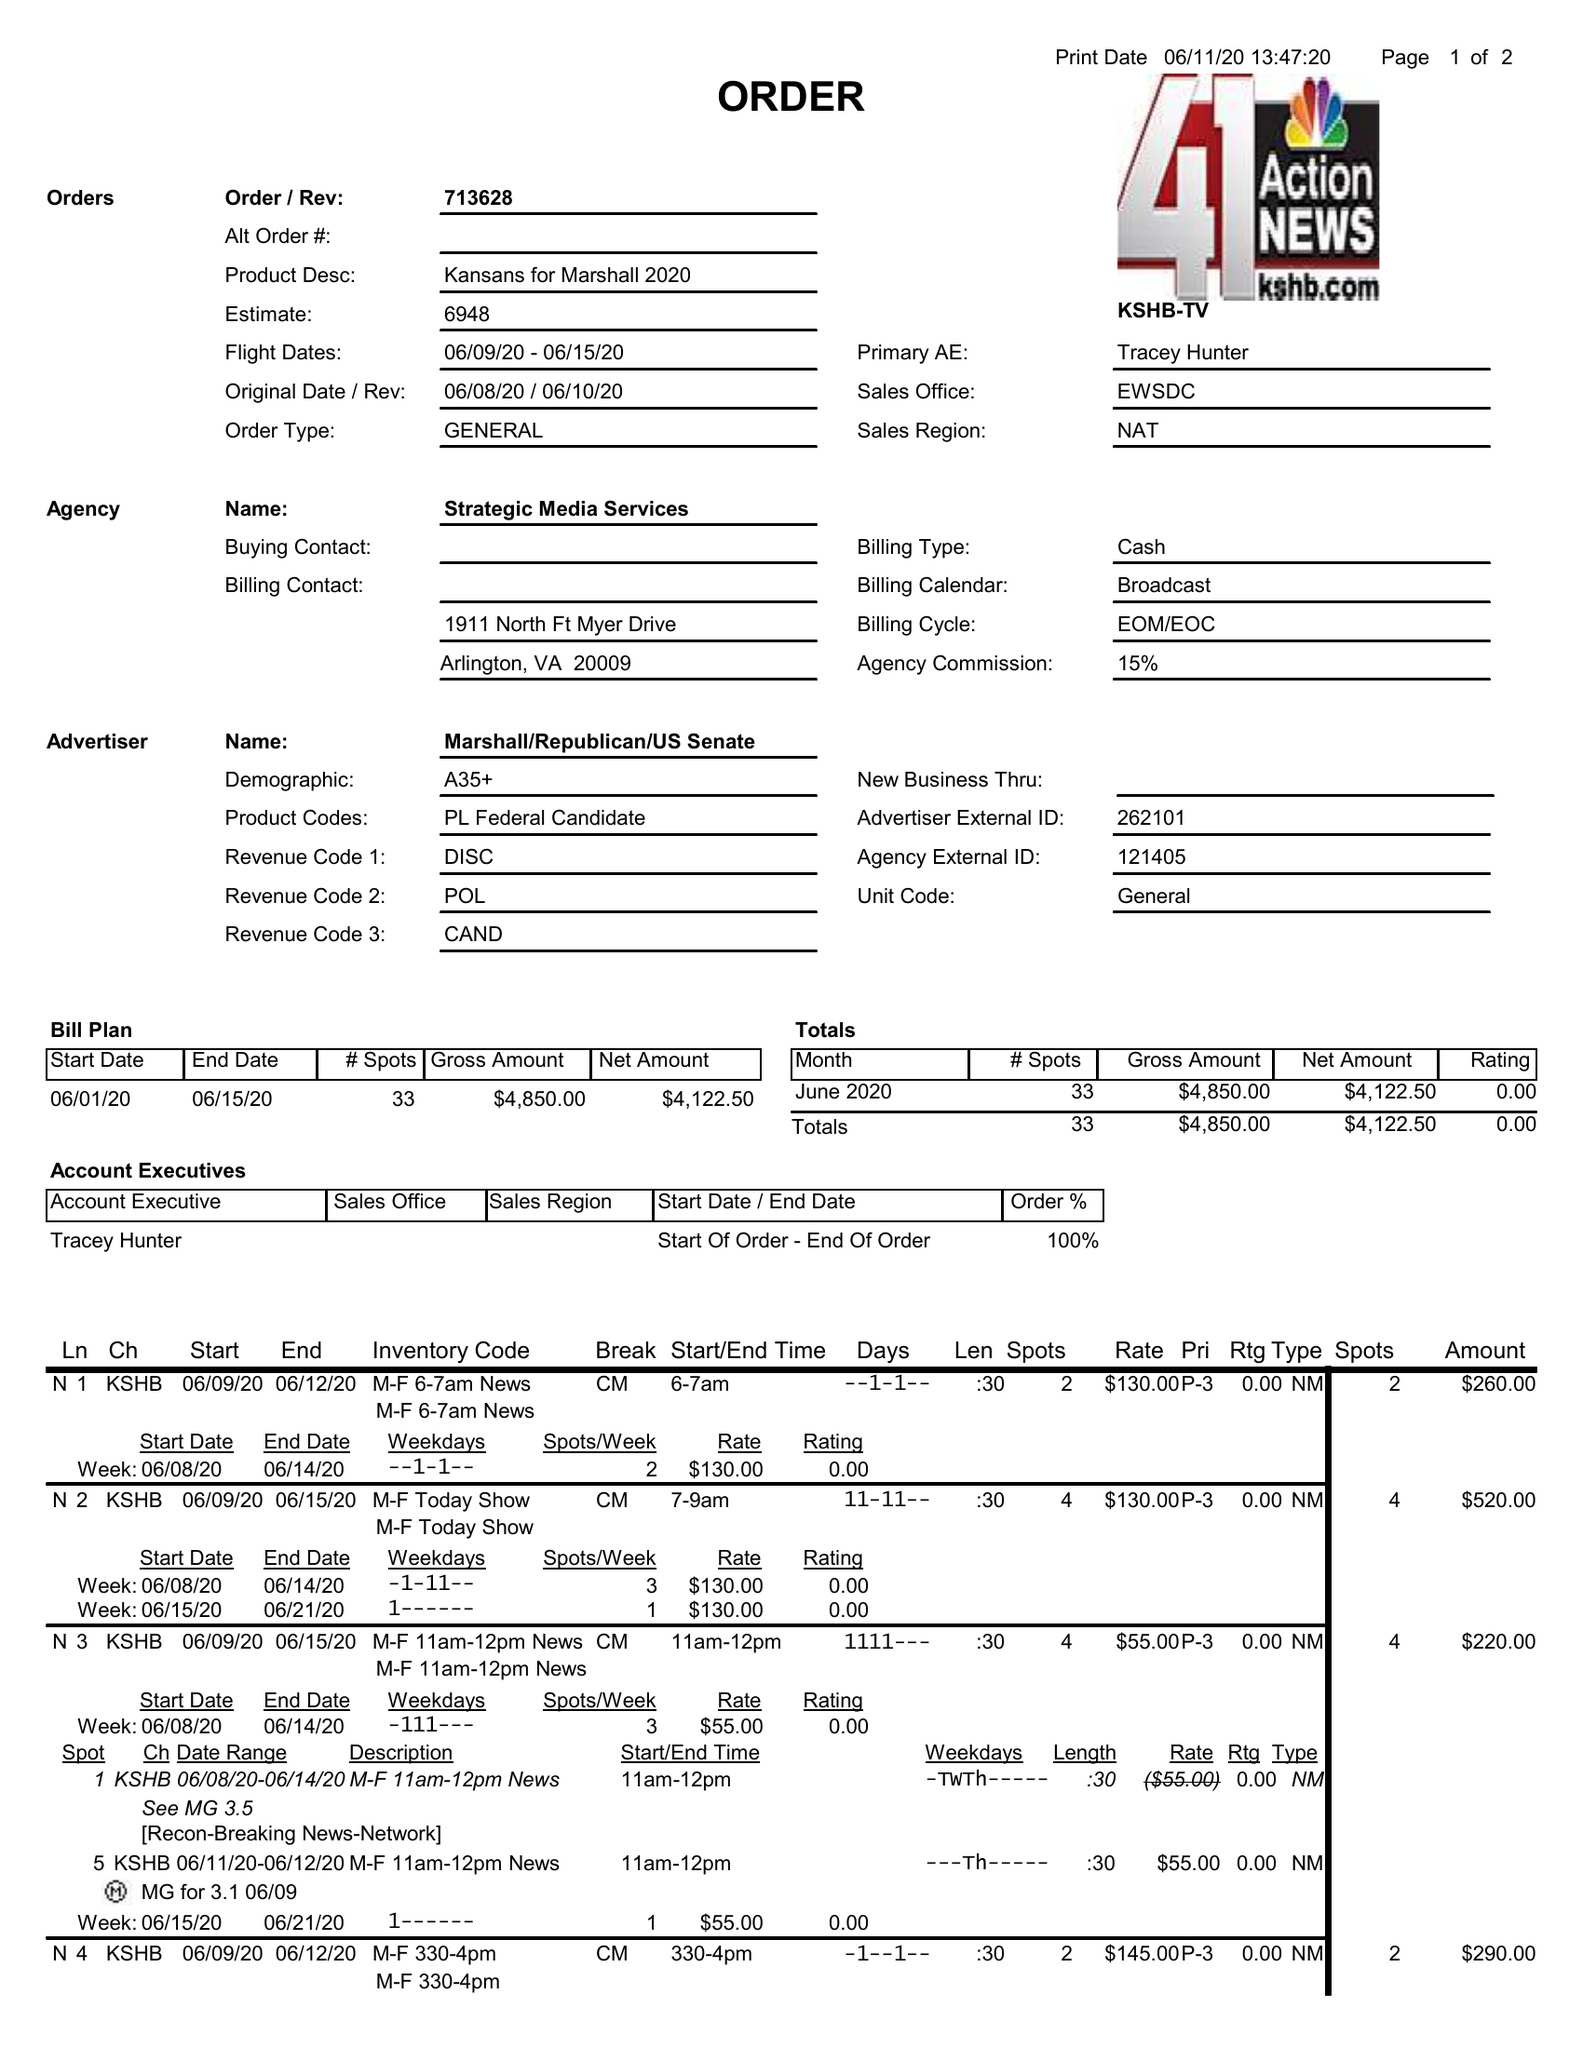What is the value for the flight_from?
Answer the question using a single word or phrase. 06/09/20 